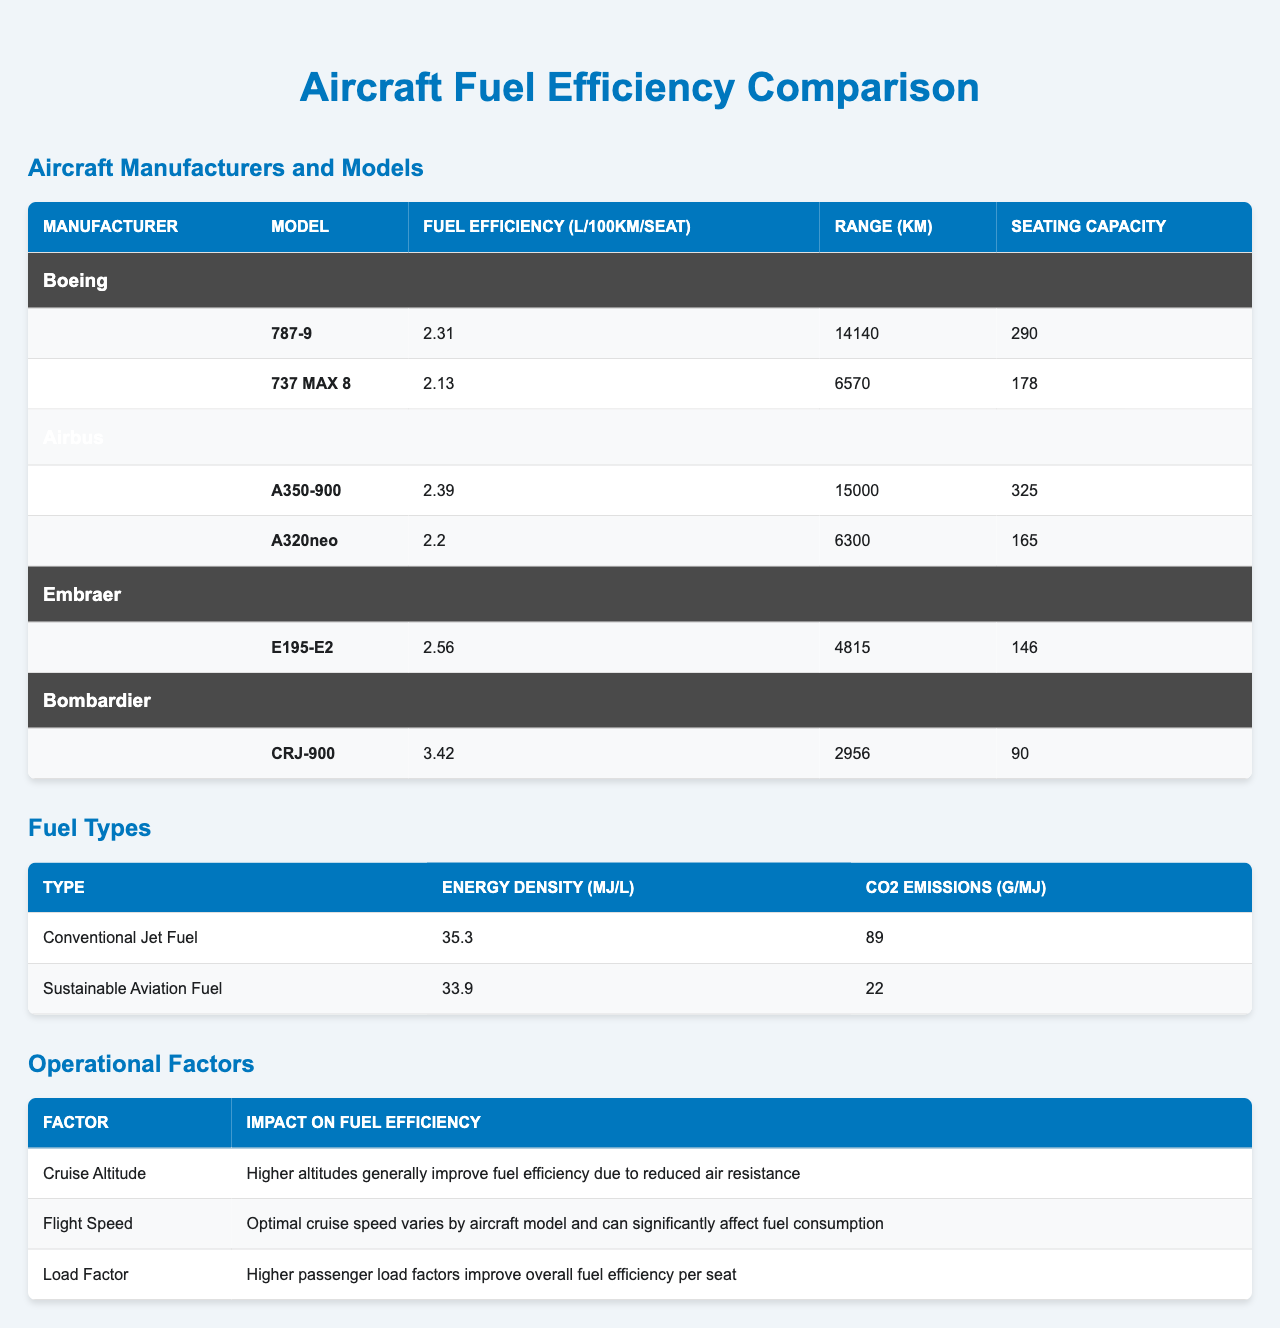What is the fuel efficiency of the Boeing 787-9? The fuel efficiency listed for the Boeing 787-9 is 2.31 L/100km/seat.
Answer: 2.31 L/100km/seat Which aircraft model has the highest fuel efficiency? By comparing all models, the lowest fuel efficiency is found in the Bombardier CRJ-900 at 3.42 L/100km/seat, while the highest is the Boeing 737 MAX 8 at 2.13 L/100km/seat.
Answer: 737 MAX 8 What is the range of the Airbus A350-900? The range for the Airbus A350-900 is given as 15000 km.
Answer: 15000 km Is the fuel efficiency of the Embraer E195-E2 better than the Airbus A320neo? The fuel efficiency of the Embraer E195-E2 is 2.56 L/100km/seat, while the Airbus A320neo has a fuel efficiency of 2.20 L/100km/seat. Since 2.56 > 2.20, the statement is false.
Answer: No What is the average fuel efficiency of all aircraft models listed? The total fuel efficiency values are 2.31, 2.13, 2.39, 2.20, 2.56, and 3.42 L/100km/seat. Adding these gives 14.01, and there are 6 models, so the average is 14.01/6 = 2.335 L/100km/seat.
Answer: 2.335 L/100km/seat Which manufacturer produces the most fuel-efficient aircraft? Comparing the fuel efficiencies from each manufacturer, Boeing has 2.31 and 2.13, Airbus has 2.39 and 2.20, Embraer has 2.56, and Bombardier has 3.42. The lowest average is from Boeing.
Answer: Boeing What impact does cruise altitude have on fuel efficiency? The table states that higher altitudes generally improve fuel efficiency due to reduced air resistance, suggesting that cruise altitude has a positive impact.
Answer: Positive impact How many seats does the Airbus A320neo have? The seating capacity of the Airbus A320neo is given as 165.
Answer: 165 seats Calculate the difference in fuel efficiency between the Boeing 737 MAX 8 and the Bombardier CRJ-900. The fuel efficiency of the 737 MAX 8 is 2.13 and for the CRJ-900 is 3.42. The difference is 3.42 - 2.13 = 1.29 L/100km/seat.
Answer: 1.29 L/100km/seat Which fuel type has lower CO2 emissions? The sustainable aviation fuel has CO2 emissions of 22 g/MJ, while conventional jet fuel has 89 g/MJ. Since 22 < 89, sustainable aviation fuel is the answer.
Answer: Sustainable Aviation Fuel 